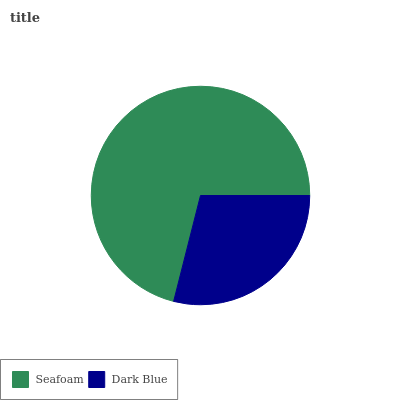Is Dark Blue the minimum?
Answer yes or no. Yes. Is Seafoam the maximum?
Answer yes or no. Yes. Is Dark Blue the maximum?
Answer yes or no. No. Is Seafoam greater than Dark Blue?
Answer yes or no. Yes. Is Dark Blue less than Seafoam?
Answer yes or no. Yes. Is Dark Blue greater than Seafoam?
Answer yes or no. No. Is Seafoam less than Dark Blue?
Answer yes or no. No. Is Seafoam the high median?
Answer yes or no. Yes. Is Dark Blue the low median?
Answer yes or no. Yes. Is Dark Blue the high median?
Answer yes or no. No. Is Seafoam the low median?
Answer yes or no. No. 